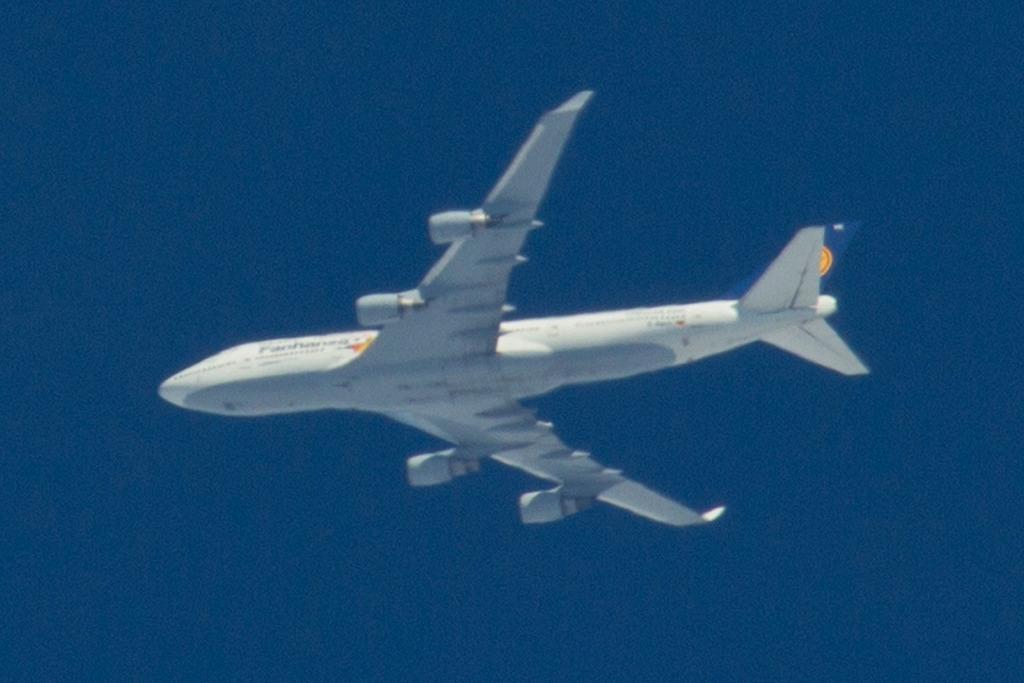How would you summarize this image in a sentence or two? In this image we can see an airplane flying in the sky. 